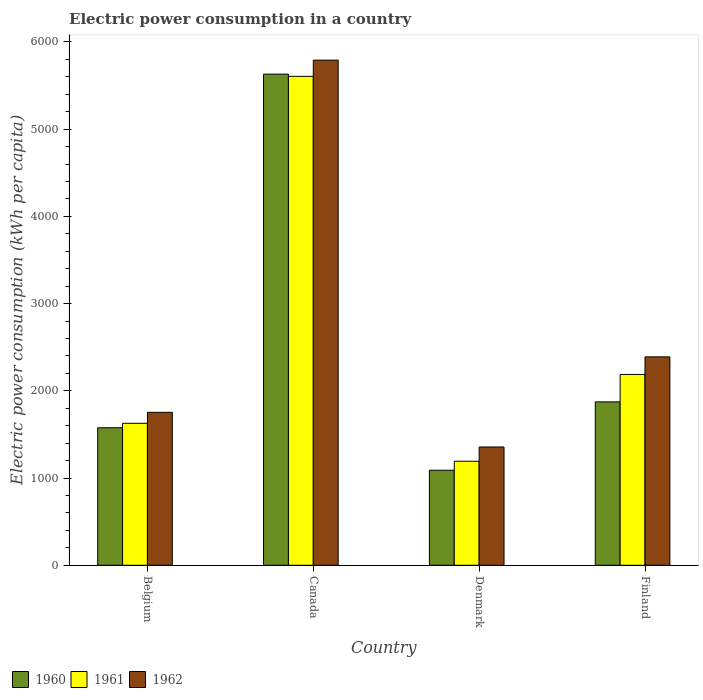How many different coloured bars are there?
Provide a short and direct response. 3. How many groups of bars are there?
Make the answer very short. 4. Are the number of bars on each tick of the X-axis equal?
Offer a terse response. Yes. How many bars are there on the 2nd tick from the left?
Offer a very short reply. 3. How many bars are there on the 4th tick from the right?
Offer a very short reply. 3. In how many cases, is the number of bars for a given country not equal to the number of legend labels?
Provide a short and direct response. 0. What is the electric power consumption in in 1961 in Finland?
Your answer should be very brief. 2187.62. Across all countries, what is the maximum electric power consumption in in 1962?
Your answer should be compact. 5791.12. Across all countries, what is the minimum electric power consumption in in 1960?
Keep it short and to the point. 1089.61. In which country was the electric power consumption in in 1961 maximum?
Offer a very short reply. Canada. What is the total electric power consumption in in 1962 in the graph?
Your answer should be compact. 1.13e+04. What is the difference between the electric power consumption in in 1960 in Canada and that in Denmark?
Give a very brief answer. 4541.02. What is the difference between the electric power consumption in in 1962 in Belgium and the electric power consumption in in 1961 in Denmark?
Your answer should be compact. 560.74. What is the average electric power consumption in in 1962 per country?
Your answer should be compact. 2822.35. What is the difference between the electric power consumption in of/in 1961 and electric power consumption in of/in 1962 in Belgium?
Offer a terse response. -125.63. What is the ratio of the electric power consumption in in 1960 in Canada to that in Finland?
Your answer should be compact. 3.01. Is the electric power consumption in in 1962 in Canada less than that in Finland?
Offer a very short reply. No. What is the difference between the highest and the second highest electric power consumption in in 1962?
Your answer should be compact. -636.07. What is the difference between the highest and the lowest electric power consumption in in 1960?
Your answer should be compact. 4541.02. Are all the bars in the graph horizontal?
Ensure brevity in your answer.  No. How many countries are there in the graph?
Your answer should be compact. 4. Does the graph contain any zero values?
Keep it short and to the point. No. Where does the legend appear in the graph?
Your response must be concise. Bottom left. What is the title of the graph?
Keep it short and to the point. Electric power consumption in a country. What is the label or title of the Y-axis?
Your answer should be compact. Electric power consumption (kWh per capita). What is the Electric power consumption (kWh per capita) of 1960 in Belgium?
Your answer should be very brief. 1576.34. What is the Electric power consumption (kWh per capita) in 1961 in Belgium?
Your answer should be compact. 1627.51. What is the Electric power consumption (kWh per capita) of 1962 in Belgium?
Ensure brevity in your answer.  1753.14. What is the Electric power consumption (kWh per capita) in 1960 in Canada?
Provide a short and direct response. 5630.63. What is the Electric power consumption (kWh per capita) in 1961 in Canada?
Offer a terse response. 5605.11. What is the Electric power consumption (kWh per capita) of 1962 in Canada?
Give a very brief answer. 5791.12. What is the Electric power consumption (kWh per capita) in 1960 in Denmark?
Offer a very short reply. 1089.61. What is the Electric power consumption (kWh per capita) in 1961 in Denmark?
Your answer should be compact. 1192.41. What is the Electric power consumption (kWh per capita) of 1962 in Denmark?
Offer a very short reply. 1355.93. What is the Electric power consumption (kWh per capita) of 1960 in Finland?
Your answer should be compact. 1873.29. What is the Electric power consumption (kWh per capita) in 1961 in Finland?
Your response must be concise. 2187.62. What is the Electric power consumption (kWh per capita) of 1962 in Finland?
Offer a very short reply. 2389.21. Across all countries, what is the maximum Electric power consumption (kWh per capita) of 1960?
Provide a succinct answer. 5630.63. Across all countries, what is the maximum Electric power consumption (kWh per capita) in 1961?
Ensure brevity in your answer.  5605.11. Across all countries, what is the maximum Electric power consumption (kWh per capita) of 1962?
Ensure brevity in your answer.  5791.12. Across all countries, what is the minimum Electric power consumption (kWh per capita) in 1960?
Ensure brevity in your answer.  1089.61. Across all countries, what is the minimum Electric power consumption (kWh per capita) in 1961?
Ensure brevity in your answer.  1192.41. Across all countries, what is the minimum Electric power consumption (kWh per capita) in 1962?
Your answer should be compact. 1355.93. What is the total Electric power consumption (kWh per capita) of 1960 in the graph?
Give a very brief answer. 1.02e+04. What is the total Electric power consumption (kWh per capita) of 1961 in the graph?
Your answer should be very brief. 1.06e+04. What is the total Electric power consumption (kWh per capita) in 1962 in the graph?
Offer a very short reply. 1.13e+04. What is the difference between the Electric power consumption (kWh per capita) in 1960 in Belgium and that in Canada?
Your answer should be very brief. -4054.29. What is the difference between the Electric power consumption (kWh per capita) of 1961 in Belgium and that in Canada?
Your response must be concise. -3977.6. What is the difference between the Electric power consumption (kWh per capita) in 1962 in Belgium and that in Canada?
Ensure brevity in your answer.  -4037.98. What is the difference between the Electric power consumption (kWh per capita) of 1960 in Belgium and that in Denmark?
Provide a succinct answer. 486.72. What is the difference between the Electric power consumption (kWh per capita) of 1961 in Belgium and that in Denmark?
Keep it short and to the point. 435.11. What is the difference between the Electric power consumption (kWh per capita) of 1962 in Belgium and that in Denmark?
Provide a succinct answer. 397.21. What is the difference between the Electric power consumption (kWh per capita) in 1960 in Belgium and that in Finland?
Your answer should be compact. -296.95. What is the difference between the Electric power consumption (kWh per capita) in 1961 in Belgium and that in Finland?
Offer a terse response. -560.11. What is the difference between the Electric power consumption (kWh per capita) in 1962 in Belgium and that in Finland?
Give a very brief answer. -636.07. What is the difference between the Electric power consumption (kWh per capita) in 1960 in Canada and that in Denmark?
Your response must be concise. 4541.02. What is the difference between the Electric power consumption (kWh per capita) in 1961 in Canada and that in Denmark?
Ensure brevity in your answer.  4412.71. What is the difference between the Electric power consumption (kWh per capita) in 1962 in Canada and that in Denmark?
Your answer should be very brief. 4435.19. What is the difference between the Electric power consumption (kWh per capita) of 1960 in Canada and that in Finland?
Your answer should be very brief. 3757.34. What is the difference between the Electric power consumption (kWh per capita) in 1961 in Canada and that in Finland?
Give a very brief answer. 3417.49. What is the difference between the Electric power consumption (kWh per capita) of 1962 in Canada and that in Finland?
Give a very brief answer. 3401.92. What is the difference between the Electric power consumption (kWh per capita) in 1960 in Denmark and that in Finland?
Provide a succinct answer. -783.68. What is the difference between the Electric power consumption (kWh per capita) in 1961 in Denmark and that in Finland?
Your response must be concise. -995.22. What is the difference between the Electric power consumption (kWh per capita) of 1962 in Denmark and that in Finland?
Ensure brevity in your answer.  -1033.28. What is the difference between the Electric power consumption (kWh per capita) of 1960 in Belgium and the Electric power consumption (kWh per capita) of 1961 in Canada?
Your answer should be compact. -4028.77. What is the difference between the Electric power consumption (kWh per capita) of 1960 in Belgium and the Electric power consumption (kWh per capita) of 1962 in Canada?
Keep it short and to the point. -4214.79. What is the difference between the Electric power consumption (kWh per capita) in 1961 in Belgium and the Electric power consumption (kWh per capita) in 1962 in Canada?
Give a very brief answer. -4163.61. What is the difference between the Electric power consumption (kWh per capita) in 1960 in Belgium and the Electric power consumption (kWh per capita) in 1961 in Denmark?
Your answer should be very brief. 383.93. What is the difference between the Electric power consumption (kWh per capita) in 1960 in Belgium and the Electric power consumption (kWh per capita) in 1962 in Denmark?
Your answer should be compact. 220.41. What is the difference between the Electric power consumption (kWh per capita) of 1961 in Belgium and the Electric power consumption (kWh per capita) of 1962 in Denmark?
Your answer should be very brief. 271.58. What is the difference between the Electric power consumption (kWh per capita) in 1960 in Belgium and the Electric power consumption (kWh per capita) in 1961 in Finland?
Keep it short and to the point. -611.28. What is the difference between the Electric power consumption (kWh per capita) of 1960 in Belgium and the Electric power consumption (kWh per capita) of 1962 in Finland?
Ensure brevity in your answer.  -812.87. What is the difference between the Electric power consumption (kWh per capita) of 1961 in Belgium and the Electric power consumption (kWh per capita) of 1962 in Finland?
Offer a terse response. -761.7. What is the difference between the Electric power consumption (kWh per capita) of 1960 in Canada and the Electric power consumption (kWh per capita) of 1961 in Denmark?
Provide a short and direct response. 4438.22. What is the difference between the Electric power consumption (kWh per capita) in 1960 in Canada and the Electric power consumption (kWh per capita) in 1962 in Denmark?
Offer a very short reply. 4274.7. What is the difference between the Electric power consumption (kWh per capita) in 1961 in Canada and the Electric power consumption (kWh per capita) in 1962 in Denmark?
Ensure brevity in your answer.  4249.18. What is the difference between the Electric power consumption (kWh per capita) of 1960 in Canada and the Electric power consumption (kWh per capita) of 1961 in Finland?
Offer a terse response. 3443.01. What is the difference between the Electric power consumption (kWh per capita) in 1960 in Canada and the Electric power consumption (kWh per capita) in 1962 in Finland?
Keep it short and to the point. 3241.42. What is the difference between the Electric power consumption (kWh per capita) in 1961 in Canada and the Electric power consumption (kWh per capita) in 1962 in Finland?
Offer a terse response. 3215.9. What is the difference between the Electric power consumption (kWh per capita) of 1960 in Denmark and the Electric power consumption (kWh per capita) of 1961 in Finland?
Your answer should be compact. -1098.01. What is the difference between the Electric power consumption (kWh per capita) of 1960 in Denmark and the Electric power consumption (kWh per capita) of 1962 in Finland?
Provide a short and direct response. -1299.6. What is the difference between the Electric power consumption (kWh per capita) in 1961 in Denmark and the Electric power consumption (kWh per capita) in 1962 in Finland?
Offer a terse response. -1196.8. What is the average Electric power consumption (kWh per capita) of 1960 per country?
Your response must be concise. 2542.47. What is the average Electric power consumption (kWh per capita) in 1961 per country?
Give a very brief answer. 2653.16. What is the average Electric power consumption (kWh per capita) of 1962 per country?
Your response must be concise. 2822.35. What is the difference between the Electric power consumption (kWh per capita) in 1960 and Electric power consumption (kWh per capita) in 1961 in Belgium?
Offer a terse response. -51.17. What is the difference between the Electric power consumption (kWh per capita) in 1960 and Electric power consumption (kWh per capita) in 1962 in Belgium?
Make the answer very short. -176.81. What is the difference between the Electric power consumption (kWh per capita) in 1961 and Electric power consumption (kWh per capita) in 1962 in Belgium?
Provide a short and direct response. -125.63. What is the difference between the Electric power consumption (kWh per capita) in 1960 and Electric power consumption (kWh per capita) in 1961 in Canada?
Your answer should be very brief. 25.52. What is the difference between the Electric power consumption (kWh per capita) in 1960 and Electric power consumption (kWh per capita) in 1962 in Canada?
Ensure brevity in your answer.  -160.5. What is the difference between the Electric power consumption (kWh per capita) in 1961 and Electric power consumption (kWh per capita) in 1962 in Canada?
Provide a succinct answer. -186.01. What is the difference between the Electric power consumption (kWh per capita) in 1960 and Electric power consumption (kWh per capita) in 1961 in Denmark?
Your answer should be very brief. -102.79. What is the difference between the Electric power consumption (kWh per capita) of 1960 and Electric power consumption (kWh per capita) of 1962 in Denmark?
Provide a succinct answer. -266.32. What is the difference between the Electric power consumption (kWh per capita) in 1961 and Electric power consumption (kWh per capita) in 1962 in Denmark?
Your answer should be compact. -163.53. What is the difference between the Electric power consumption (kWh per capita) of 1960 and Electric power consumption (kWh per capita) of 1961 in Finland?
Give a very brief answer. -314.33. What is the difference between the Electric power consumption (kWh per capita) of 1960 and Electric power consumption (kWh per capita) of 1962 in Finland?
Offer a very short reply. -515.92. What is the difference between the Electric power consumption (kWh per capita) of 1961 and Electric power consumption (kWh per capita) of 1962 in Finland?
Give a very brief answer. -201.59. What is the ratio of the Electric power consumption (kWh per capita) of 1960 in Belgium to that in Canada?
Provide a short and direct response. 0.28. What is the ratio of the Electric power consumption (kWh per capita) in 1961 in Belgium to that in Canada?
Give a very brief answer. 0.29. What is the ratio of the Electric power consumption (kWh per capita) of 1962 in Belgium to that in Canada?
Your answer should be very brief. 0.3. What is the ratio of the Electric power consumption (kWh per capita) of 1960 in Belgium to that in Denmark?
Provide a short and direct response. 1.45. What is the ratio of the Electric power consumption (kWh per capita) of 1961 in Belgium to that in Denmark?
Your answer should be very brief. 1.36. What is the ratio of the Electric power consumption (kWh per capita) of 1962 in Belgium to that in Denmark?
Make the answer very short. 1.29. What is the ratio of the Electric power consumption (kWh per capita) of 1960 in Belgium to that in Finland?
Your response must be concise. 0.84. What is the ratio of the Electric power consumption (kWh per capita) in 1961 in Belgium to that in Finland?
Provide a succinct answer. 0.74. What is the ratio of the Electric power consumption (kWh per capita) in 1962 in Belgium to that in Finland?
Provide a short and direct response. 0.73. What is the ratio of the Electric power consumption (kWh per capita) of 1960 in Canada to that in Denmark?
Make the answer very short. 5.17. What is the ratio of the Electric power consumption (kWh per capita) of 1961 in Canada to that in Denmark?
Your answer should be compact. 4.7. What is the ratio of the Electric power consumption (kWh per capita) in 1962 in Canada to that in Denmark?
Your answer should be very brief. 4.27. What is the ratio of the Electric power consumption (kWh per capita) in 1960 in Canada to that in Finland?
Keep it short and to the point. 3.01. What is the ratio of the Electric power consumption (kWh per capita) of 1961 in Canada to that in Finland?
Make the answer very short. 2.56. What is the ratio of the Electric power consumption (kWh per capita) in 1962 in Canada to that in Finland?
Your response must be concise. 2.42. What is the ratio of the Electric power consumption (kWh per capita) in 1960 in Denmark to that in Finland?
Provide a short and direct response. 0.58. What is the ratio of the Electric power consumption (kWh per capita) in 1961 in Denmark to that in Finland?
Give a very brief answer. 0.55. What is the ratio of the Electric power consumption (kWh per capita) of 1962 in Denmark to that in Finland?
Make the answer very short. 0.57. What is the difference between the highest and the second highest Electric power consumption (kWh per capita) of 1960?
Offer a very short reply. 3757.34. What is the difference between the highest and the second highest Electric power consumption (kWh per capita) in 1961?
Keep it short and to the point. 3417.49. What is the difference between the highest and the second highest Electric power consumption (kWh per capita) in 1962?
Give a very brief answer. 3401.92. What is the difference between the highest and the lowest Electric power consumption (kWh per capita) of 1960?
Give a very brief answer. 4541.02. What is the difference between the highest and the lowest Electric power consumption (kWh per capita) in 1961?
Ensure brevity in your answer.  4412.71. What is the difference between the highest and the lowest Electric power consumption (kWh per capita) in 1962?
Offer a terse response. 4435.19. 